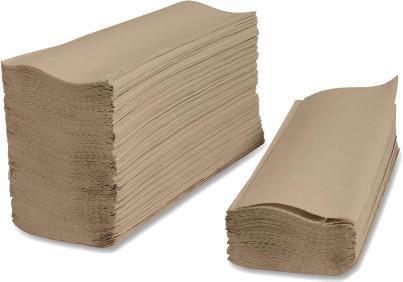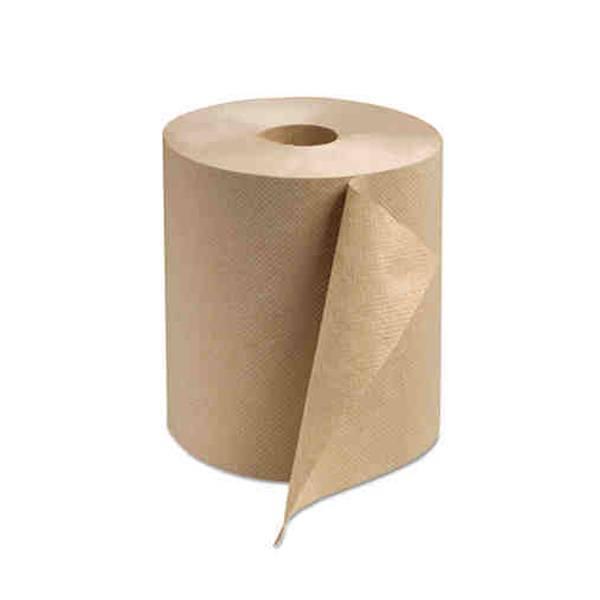The first image is the image on the left, the second image is the image on the right. Assess this claim about the two images: "The roll of brown paper in the image on the right is partially unrolled.". Correct or not? Answer yes or no. Yes. The first image is the image on the left, the second image is the image on the right. Considering the images on both sides, is "There are two paper towel rolls" valid? Answer yes or no. No. 